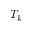Convert formula to latex. <formula><loc_0><loc_0><loc_500><loc_500>T _ { k }</formula> 